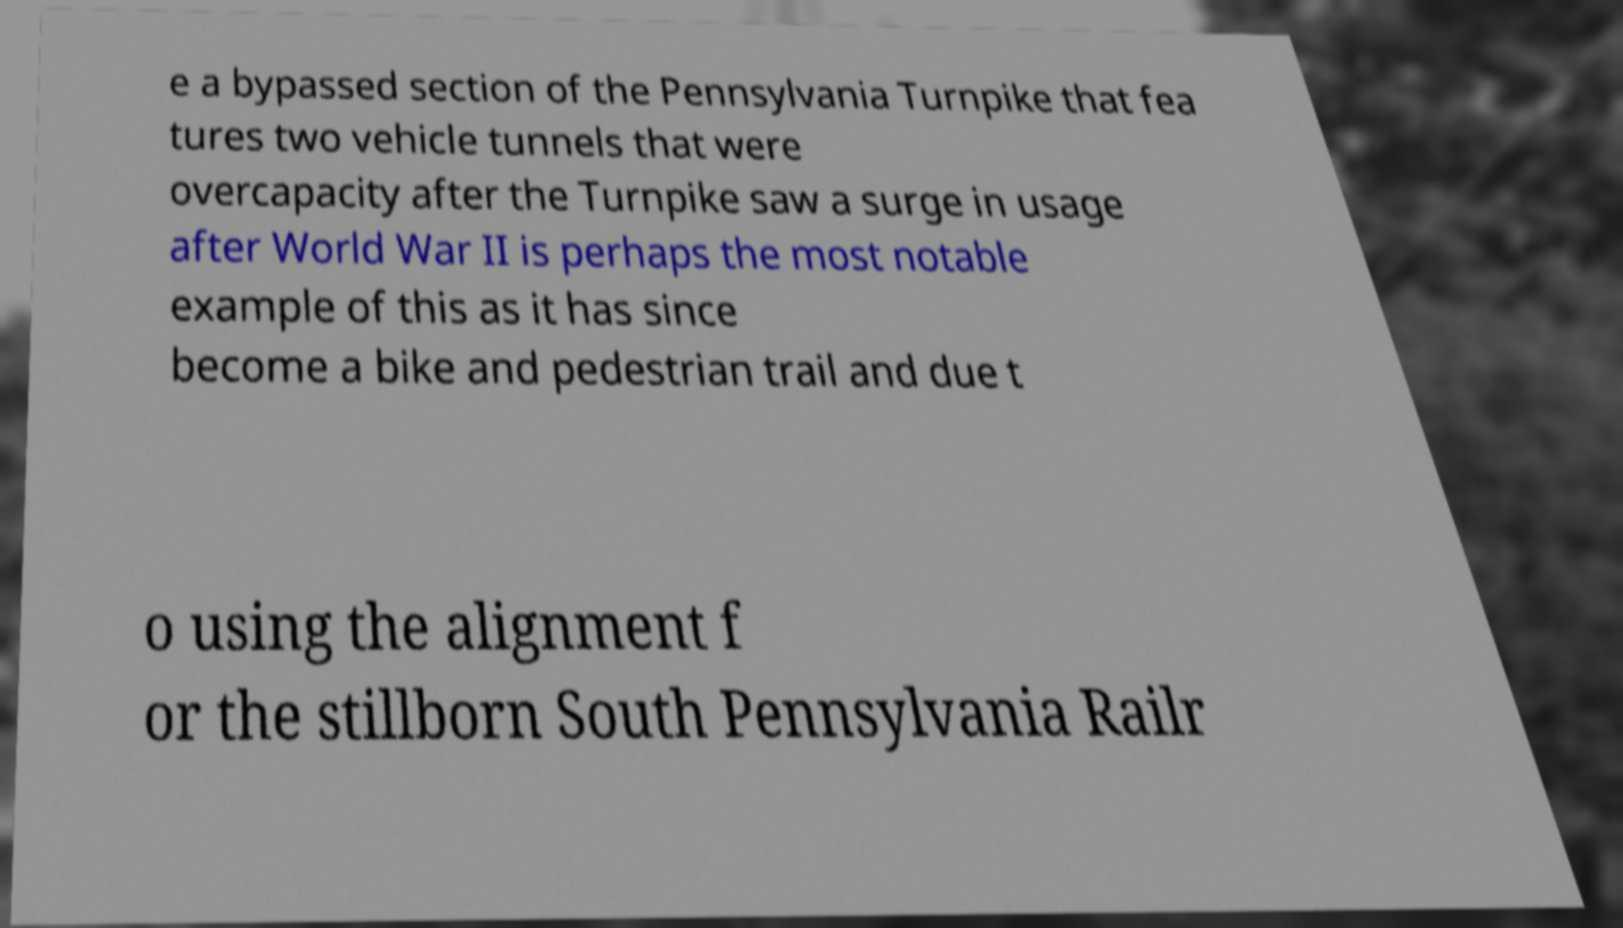For documentation purposes, I need the text within this image transcribed. Could you provide that? e a bypassed section of the Pennsylvania Turnpike that fea tures two vehicle tunnels that were overcapacity after the Turnpike saw a surge in usage after World War II is perhaps the most notable example of this as it has since become a bike and pedestrian trail and due t o using the alignment f or the stillborn South Pennsylvania Railr 